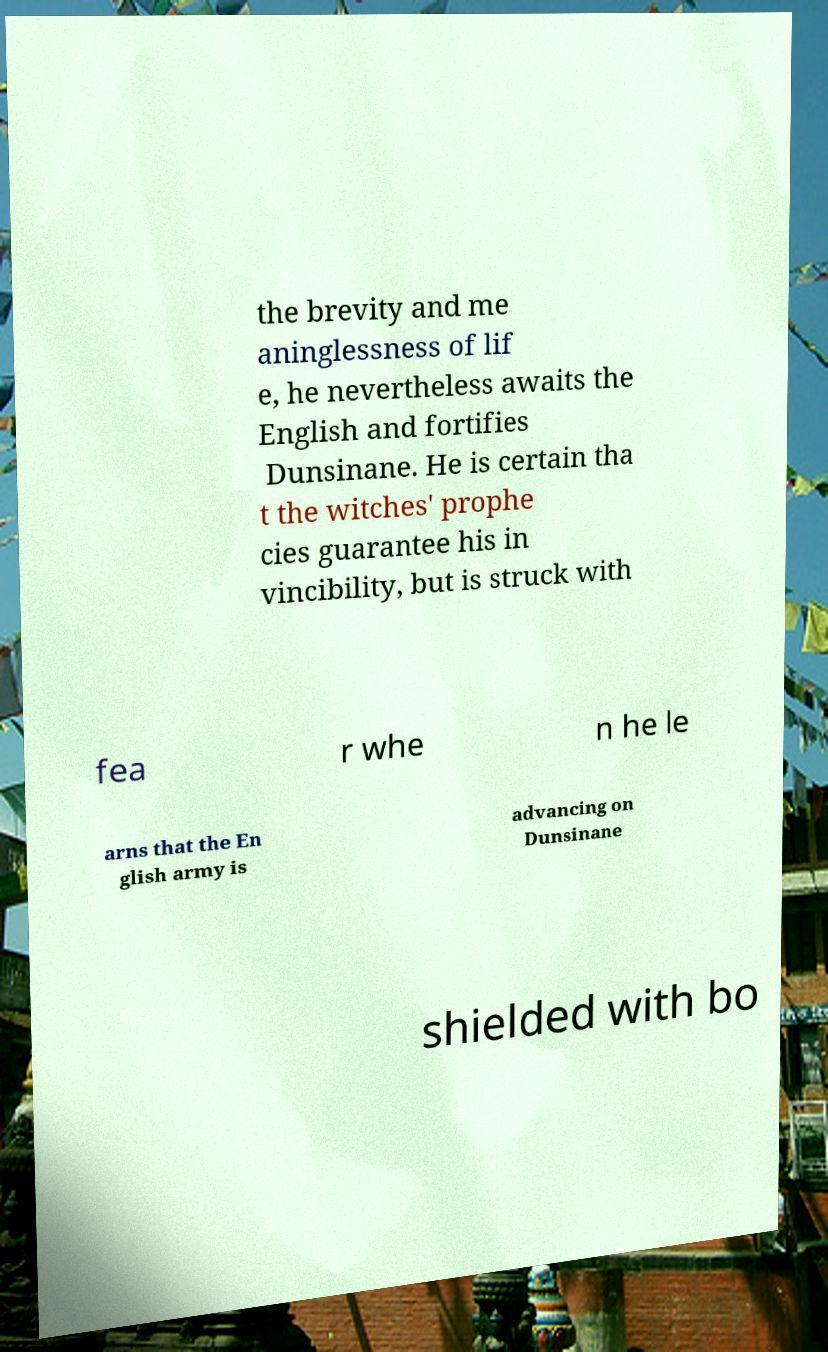Can you accurately transcribe the text from the provided image for me? the brevity and me aninglessness of lif e, he nevertheless awaits the English and fortifies Dunsinane. He is certain tha t the witches' prophe cies guarantee his in vincibility, but is struck with fea r whe n he le arns that the En glish army is advancing on Dunsinane shielded with bo 